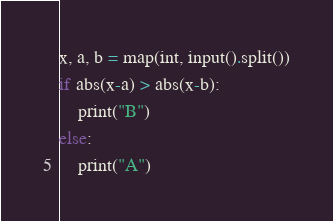Convert code to text. <code><loc_0><loc_0><loc_500><loc_500><_Python_>x, a, b = map(int, input().split())
if abs(x-a) > abs(x-b):
    print("B")
else:
    print("A")
</code> 